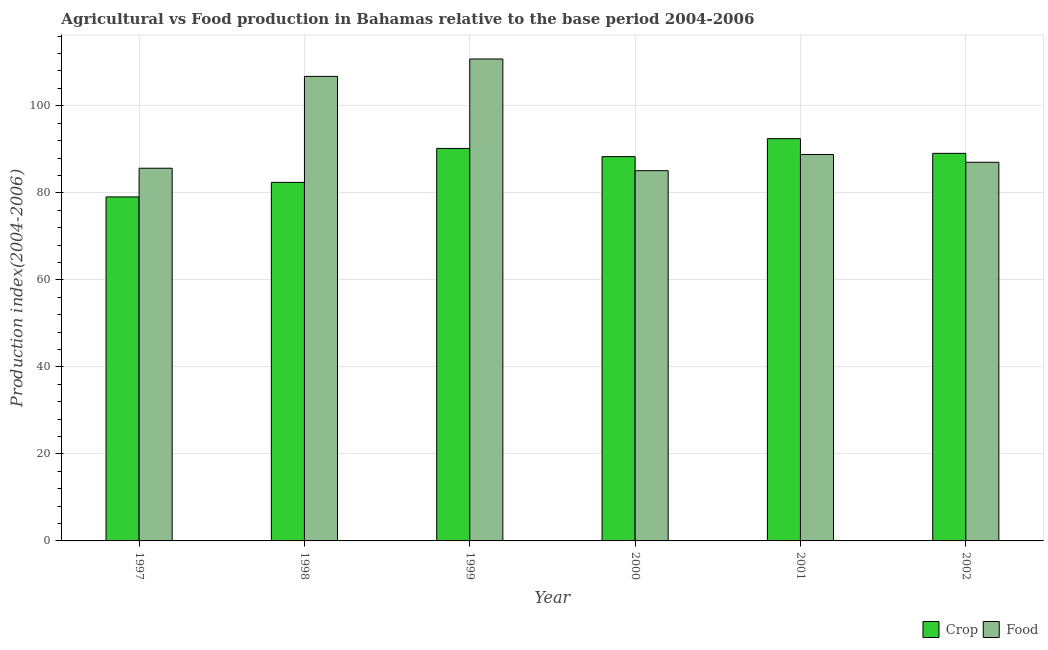Are the number of bars per tick equal to the number of legend labels?
Make the answer very short. Yes. Are the number of bars on each tick of the X-axis equal?
Make the answer very short. Yes. How many bars are there on the 4th tick from the right?
Provide a succinct answer. 2. What is the label of the 4th group of bars from the left?
Your answer should be compact. 2000. In how many cases, is the number of bars for a given year not equal to the number of legend labels?
Offer a terse response. 0. What is the crop production index in 2002?
Provide a succinct answer. 89.07. Across all years, what is the maximum food production index?
Provide a succinct answer. 110.76. Across all years, what is the minimum crop production index?
Make the answer very short. 79.06. What is the total crop production index in the graph?
Provide a succinct answer. 521.5. What is the difference between the crop production index in 1999 and that in 2000?
Your answer should be very brief. 1.88. What is the difference between the crop production index in 2001 and the food production index in 2000?
Provide a succinct answer. 4.13. What is the average food production index per year?
Give a very brief answer. 94.02. What is the ratio of the food production index in 1997 to that in 1999?
Give a very brief answer. 0.77. Is the crop production index in 2000 less than that in 2001?
Ensure brevity in your answer.  Yes. Is the difference between the crop production index in 1997 and 2001 greater than the difference between the food production index in 1997 and 2001?
Your response must be concise. No. What is the difference between the highest and the second highest food production index?
Make the answer very short. 4. What is the difference between the highest and the lowest food production index?
Ensure brevity in your answer.  25.67. In how many years, is the food production index greater than the average food production index taken over all years?
Your answer should be very brief. 2. Is the sum of the crop production index in 2000 and 2001 greater than the maximum food production index across all years?
Your response must be concise. Yes. What does the 1st bar from the left in 2002 represents?
Give a very brief answer. Crop. What does the 2nd bar from the right in 1997 represents?
Provide a succinct answer. Crop. How many bars are there?
Offer a very short reply. 12. Are all the bars in the graph horizontal?
Your answer should be compact. No. How many years are there in the graph?
Provide a succinct answer. 6. How many legend labels are there?
Your answer should be very brief. 2. How are the legend labels stacked?
Provide a succinct answer. Horizontal. What is the title of the graph?
Provide a short and direct response. Agricultural vs Food production in Bahamas relative to the base period 2004-2006. What is the label or title of the Y-axis?
Offer a terse response. Production index(2004-2006). What is the Production index(2004-2006) of Crop in 1997?
Offer a terse response. 79.06. What is the Production index(2004-2006) of Food in 1997?
Offer a terse response. 85.65. What is the Production index(2004-2006) in Crop in 1998?
Give a very brief answer. 82.4. What is the Production index(2004-2006) in Food in 1998?
Your answer should be compact. 106.76. What is the Production index(2004-2006) in Crop in 1999?
Ensure brevity in your answer.  90.2. What is the Production index(2004-2006) in Food in 1999?
Make the answer very short. 110.76. What is the Production index(2004-2006) of Crop in 2000?
Give a very brief answer. 88.32. What is the Production index(2004-2006) of Food in 2000?
Provide a short and direct response. 85.09. What is the Production index(2004-2006) in Crop in 2001?
Provide a succinct answer. 92.45. What is the Production index(2004-2006) in Food in 2001?
Give a very brief answer. 88.81. What is the Production index(2004-2006) of Crop in 2002?
Your answer should be very brief. 89.07. What is the Production index(2004-2006) of Food in 2002?
Make the answer very short. 87.02. Across all years, what is the maximum Production index(2004-2006) of Crop?
Keep it short and to the point. 92.45. Across all years, what is the maximum Production index(2004-2006) of Food?
Your answer should be compact. 110.76. Across all years, what is the minimum Production index(2004-2006) in Crop?
Your answer should be very brief. 79.06. Across all years, what is the minimum Production index(2004-2006) of Food?
Offer a very short reply. 85.09. What is the total Production index(2004-2006) of Crop in the graph?
Your answer should be compact. 521.5. What is the total Production index(2004-2006) of Food in the graph?
Offer a very short reply. 564.09. What is the difference between the Production index(2004-2006) in Crop in 1997 and that in 1998?
Your answer should be very brief. -3.34. What is the difference between the Production index(2004-2006) of Food in 1997 and that in 1998?
Your response must be concise. -21.11. What is the difference between the Production index(2004-2006) in Crop in 1997 and that in 1999?
Ensure brevity in your answer.  -11.14. What is the difference between the Production index(2004-2006) in Food in 1997 and that in 1999?
Your answer should be compact. -25.11. What is the difference between the Production index(2004-2006) of Crop in 1997 and that in 2000?
Offer a very short reply. -9.26. What is the difference between the Production index(2004-2006) in Food in 1997 and that in 2000?
Give a very brief answer. 0.56. What is the difference between the Production index(2004-2006) in Crop in 1997 and that in 2001?
Provide a succinct answer. -13.39. What is the difference between the Production index(2004-2006) in Food in 1997 and that in 2001?
Provide a succinct answer. -3.16. What is the difference between the Production index(2004-2006) in Crop in 1997 and that in 2002?
Provide a short and direct response. -10.01. What is the difference between the Production index(2004-2006) of Food in 1997 and that in 2002?
Offer a very short reply. -1.37. What is the difference between the Production index(2004-2006) of Crop in 1998 and that in 1999?
Provide a succinct answer. -7.8. What is the difference between the Production index(2004-2006) in Crop in 1998 and that in 2000?
Offer a very short reply. -5.92. What is the difference between the Production index(2004-2006) in Food in 1998 and that in 2000?
Your answer should be very brief. 21.67. What is the difference between the Production index(2004-2006) of Crop in 1998 and that in 2001?
Make the answer very short. -10.05. What is the difference between the Production index(2004-2006) in Food in 1998 and that in 2001?
Your answer should be very brief. 17.95. What is the difference between the Production index(2004-2006) of Crop in 1998 and that in 2002?
Your answer should be very brief. -6.67. What is the difference between the Production index(2004-2006) in Food in 1998 and that in 2002?
Ensure brevity in your answer.  19.74. What is the difference between the Production index(2004-2006) in Crop in 1999 and that in 2000?
Your response must be concise. 1.88. What is the difference between the Production index(2004-2006) in Food in 1999 and that in 2000?
Your response must be concise. 25.67. What is the difference between the Production index(2004-2006) in Crop in 1999 and that in 2001?
Give a very brief answer. -2.25. What is the difference between the Production index(2004-2006) of Food in 1999 and that in 2001?
Make the answer very short. 21.95. What is the difference between the Production index(2004-2006) in Crop in 1999 and that in 2002?
Keep it short and to the point. 1.13. What is the difference between the Production index(2004-2006) of Food in 1999 and that in 2002?
Provide a short and direct response. 23.74. What is the difference between the Production index(2004-2006) in Crop in 2000 and that in 2001?
Your response must be concise. -4.13. What is the difference between the Production index(2004-2006) in Food in 2000 and that in 2001?
Ensure brevity in your answer.  -3.72. What is the difference between the Production index(2004-2006) in Crop in 2000 and that in 2002?
Your response must be concise. -0.75. What is the difference between the Production index(2004-2006) of Food in 2000 and that in 2002?
Offer a terse response. -1.93. What is the difference between the Production index(2004-2006) in Crop in 2001 and that in 2002?
Your response must be concise. 3.38. What is the difference between the Production index(2004-2006) in Food in 2001 and that in 2002?
Offer a terse response. 1.79. What is the difference between the Production index(2004-2006) of Crop in 1997 and the Production index(2004-2006) of Food in 1998?
Provide a short and direct response. -27.7. What is the difference between the Production index(2004-2006) of Crop in 1997 and the Production index(2004-2006) of Food in 1999?
Provide a succinct answer. -31.7. What is the difference between the Production index(2004-2006) of Crop in 1997 and the Production index(2004-2006) of Food in 2000?
Make the answer very short. -6.03. What is the difference between the Production index(2004-2006) in Crop in 1997 and the Production index(2004-2006) in Food in 2001?
Your response must be concise. -9.75. What is the difference between the Production index(2004-2006) in Crop in 1997 and the Production index(2004-2006) in Food in 2002?
Your answer should be very brief. -7.96. What is the difference between the Production index(2004-2006) in Crop in 1998 and the Production index(2004-2006) in Food in 1999?
Your answer should be very brief. -28.36. What is the difference between the Production index(2004-2006) in Crop in 1998 and the Production index(2004-2006) in Food in 2000?
Provide a succinct answer. -2.69. What is the difference between the Production index(2004-2006) of Crop in 1998 and the Production index(2004-2006) of Food in 2001?
Provide a short and direct response. -6.41. What is the difference between the Production index(2004-2006) of Crop in 1998 and the Production index(2004-2006) of Food in 2002?
Offer a terse response. -4.62. What is the difference between the Production index(2004-2006) in Crop in 1999 and the Production index(2004-2006) in Food in 2000?
Ensure brevity in your answer.  5.11. What is the difference between the Production index(2004-2006) of Crop in 1999 and the Production index(2004-2006) of Food in 2001?
Offer a terse response. 1.39. What is the difference between the Production index(2004-2006) of Crop in 1999 and the Production index(2004-2006) of Food in 2002?
Make the answer very short. 3.18. What is the difference between the Production index(2004-2006) of Crop in 2000 and the Production index(2004-2006) of Food in 2001?
Provide a short and direct response. -0.49. What is the difference between the Production index(2004-2006) of Crop in 2000 and the Production index(2004-2006) of Food in 2002?
Keep it short and to the point. 1.3. What is the difference between the Production index(2004-2006) in Crop in 2001 and the Production index(2004-2006) in Food in 2002?
Offer a terse response. 5.43. What is the average Production index(2004-2006) in Crop per year?
Offer a terse response. 86.92. What is the average Production index(2004-2006) in Food per year?
Ensure brevity in your answer.  94.02. In the year 1997, what is the difference between the Production index(2004-2006) of Crop and Production index(2004-2006) of Food?
Make the answer very short. -6.59. In the year 1998, what is the difference between the Production index(2004-2006) in Crop and Production index(2004-2006) in Food?
Provide a succinct answer. -24.36. In the year 1999, what is the difference between the Production index(2004-2006) in Crop and Production index(2004-2006) in Food?
Ensure brevity in your answer.  -20.56. In the year 2000, what is the difference between the Production index(2004-2006) in Crop and Production index(2004-2006) in Food?
Make the answer very short. 3.23. In the year 2001, what is the difference between the Production index(2004-2006) in Crop and Production index(2004-2006) in Food?
Offer a very short reply. 3.64. In the year 2002, what is the difference between the Production index(2004-2006) in Crop and Production index(2004-2006) in Food?
Provide a short and direct response. 2.05. What is the ratio of the Production index(2004-2006) of Crop in 1997 to that in 1998?
Ensure brevity in your answer.  0.96. What is the ratio of the Production index(2004-2006) of Food in 1997 to that in 1998?
Your answer should be compact. 0.8. What is the ratio of the Production index(2004-2006) in Crop in 1997 to that in 1999?
Keep it short and to the point. 0.88. What is the ratio of the Production index(2004-2006) in Food in 1997 to that in 1999?
Ensure brevity in your answer.  0.77. What is the ratio of the Production index(2004-2006) in Crop in 1997 to that in 2000?
Provide a succinct answer. 0.9. What is the ratio of the Production index(2004-2006) in Food in 1997 to that in 2000?
Provide a short and direct response. 1.01. What is the ratio of the Production index(2004-2006) of Crop in 1997 to that in 2001?
Your answer should be very brief. 0.86. What is the ratio of the Production index(2004-2006) of Food in 1997 to that in 2001?
Make the answer very short. 0.96. What is the ratio of the Production index(2004-2006) in Crop in 1997 to that in 2002?
Provide a succinct answer. 0.89. What is the ratio of the Production index(2004-2006) of Food in 1997 to that in 2002?
Ensure brevity in your answer.  0.98. What is the ratio of the Production index(2004-2006) in Crop in 1998 to that in 1999?
Ensure brevity in your answer.  0.91. What is the ratio of the Production index(2004-2006) in Food in 1998 to that in 1999?
Your answer should be compact. 0.96. What is the ratio of the Production index(2004-2006) of Crop in 1998 to that in 2000?
Offer a very short reply. 0.93. What is the ratio of the Production index(2004-2006) in Food in 1998 to that in 2000?
Keep it short and to the point. 1.25. What is the ratio of the Production index(2004-2006) in Crop in 1998 to that in 2001?
Keep it short and to the point. 0.89. What is the ratio of the Production index(2004-2006) of Food in 1998 to that in 2001?
Offer a terse response. 1.2. What is the ratio of the Production index(2004-2006) of Crop in 1998 to that in 2002?
Your answer should be very brief. 0.93. What is the ratio of the Production index(2004-2006) in Food in 1998 to that in 2002?
Provide a short and direct response. 1.23. What is the ratio of the Production index(2004-2006) of Crop in 1999 to that in 2000?
Make the answer very short. 1.02. What is the ratio of the Production index(2004-2006) in Food in 1999 to that in 2000?
Provide a succinct answer. 1.3. What is the ratio of the Production index(2004-2006) of Crop in 1999 to that in 2001?
Offer a terse response. 0.98. What is the ratio of the Production index(2004-2006) of Food in 1999 to that in 2001?
Give a very brief answer. 1.25. What is the ratio of the Production index(2004-2006) of Crop in 1999 to that in 2002?
Give a very brief answer. 1.01. What is the ratio of the Production index(2004-2006) in Food in 1999 to that in 2002?
Keep it short and to the point. 1.27. What is the ratio of the Production index(2004-2006) of Crop in 2000 to that in 2001?
Ensure brevity in your answer.  0.96. What is the ratio of the Production index(2004-2006) of Food in 2000 to that in 2001?
Make the answer very short. 0.96. What is the ratio of the Production index(2004-2006) of Crop in 2000 to that in 2002?
Ensure brevity in your answer.  0.99. What is the ratio of the Production index(2004-2006) of Food in 2000 to that in 2002?
Ensure brevity in your answer.  0.98. What is the ratio of the Production index(2004-2006) of Crop in 2001 to that in 2002?
Ensure brevity in your answer.  1.04. What is the ratio of the Production index(2004-2006) in Food in 2001 to that in 2002?
Offer a terse response. 1.02. What is the difference between the highest and the second highest Production index(2004-2006) in Crop?
Your answer should be compact. 2.25. What is the difference between the highest and the lowest Production index(2004-2006) in Crop?
Offer a very short reply. 13.39. What is the difference between the highest and the lowest Production index(2004-2006) of Food?
Your response must be concise. 25.67. 